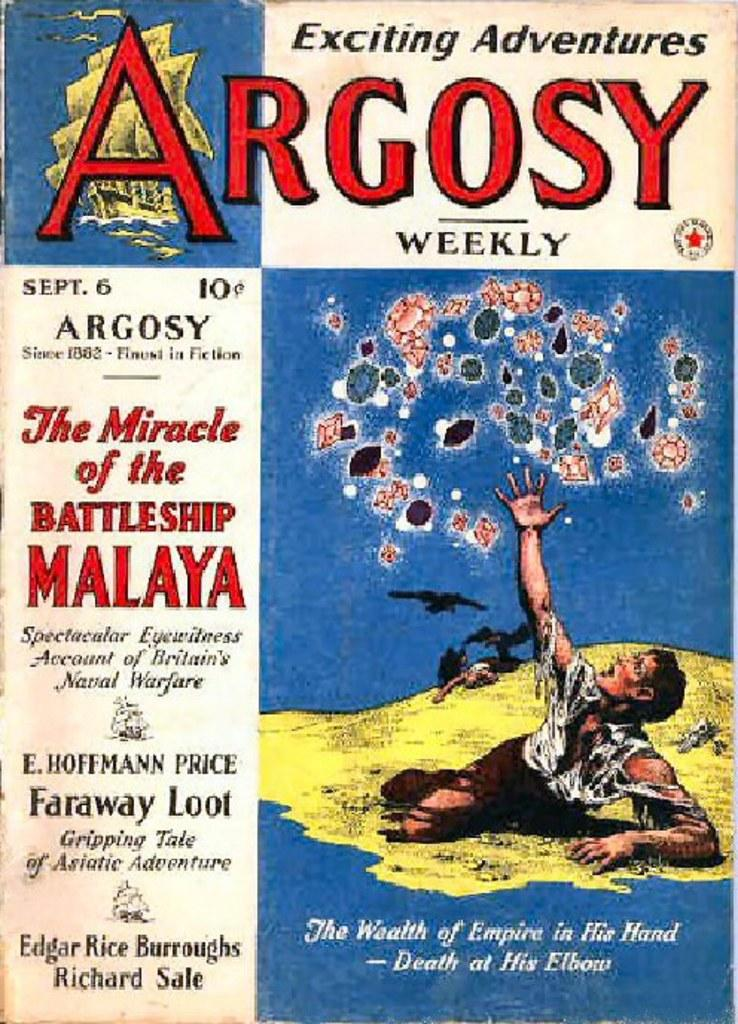Provide a one-sentence caption for the provided image. Exciting Adventures Argosy weekly book including The Miracle of the Battleship Malaya. 